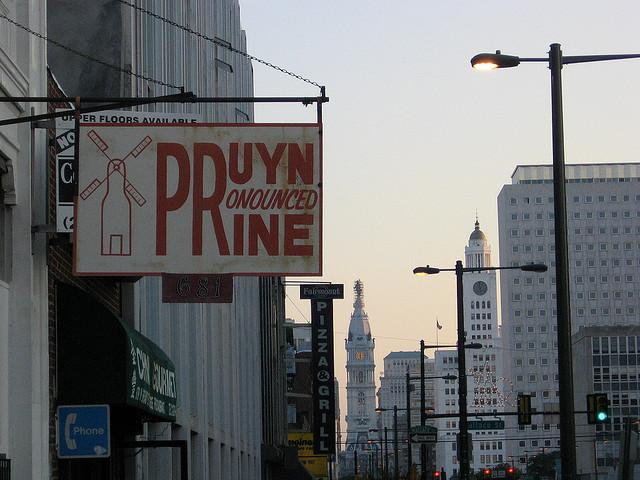Which way is illegal to turn on the upcoming cross street? right 